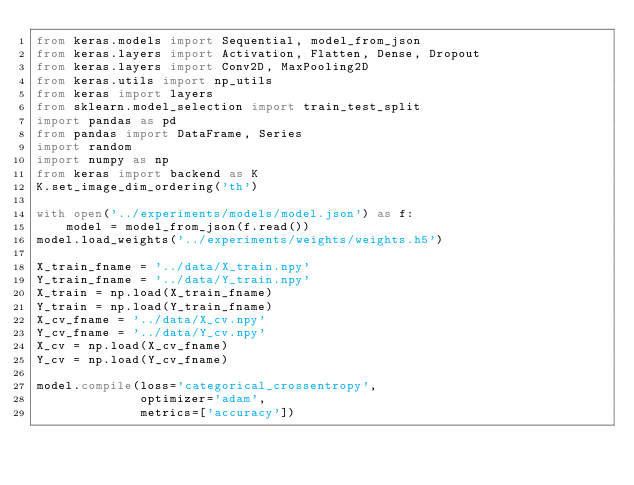<code> <loc_0><loc_0><loc_500><loc_500><_Python_>from keras.models import Sequential, model_from_json
from keras.layers import Activation, Flatten, Dense, Dropout
from keras.layers import Conv2D, MaxPooling2D
from keras.utils import np_utils
from keras import layers
from sklearn.model_selection import train_test_split
import pandas as pd
from pandas import DataFrame, Series
import random
import numpy as np
from keras import backend as K
K.set_image_dim_ordering('th')

with open('../experiments/models/model.json') as f:
    model = model_from_json(f.read())
model.load_weights('../experiments/weights/weights.h5')

X_train_fname = '../data/X_train.npy'
Y_train_fname = '../data/Y_train.npy'
X_train = np.load(X_train_fname)
Y_train = np.load(Y_train_fname)
X_cv_fname = '../data/X_cv.npy'
Y_cv_fname = '../data/Y_cv.npy'
X_cv = np.load(X_cv_fname)
Y_cv = np.load(Y_cv_fname)

model.compile(loss='categorical_crossentropy',
              optimizer='adam',
              metrics=['accuracy'])</code> 